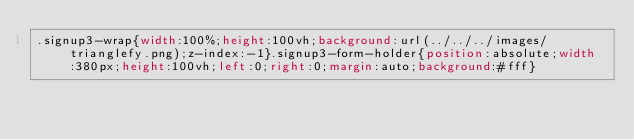<code> <loc_0><loc_0><loc_500><loc_500><_CSS_>.signup3-wrap{width:100%;height:100vh;background:url(../../../images/trianglefy.png);z-index:-1}.signup3-form-holder{position:absolute;width:380px;height:100vh;left:0;right:0;margin:auto;background:#fff}</code> 